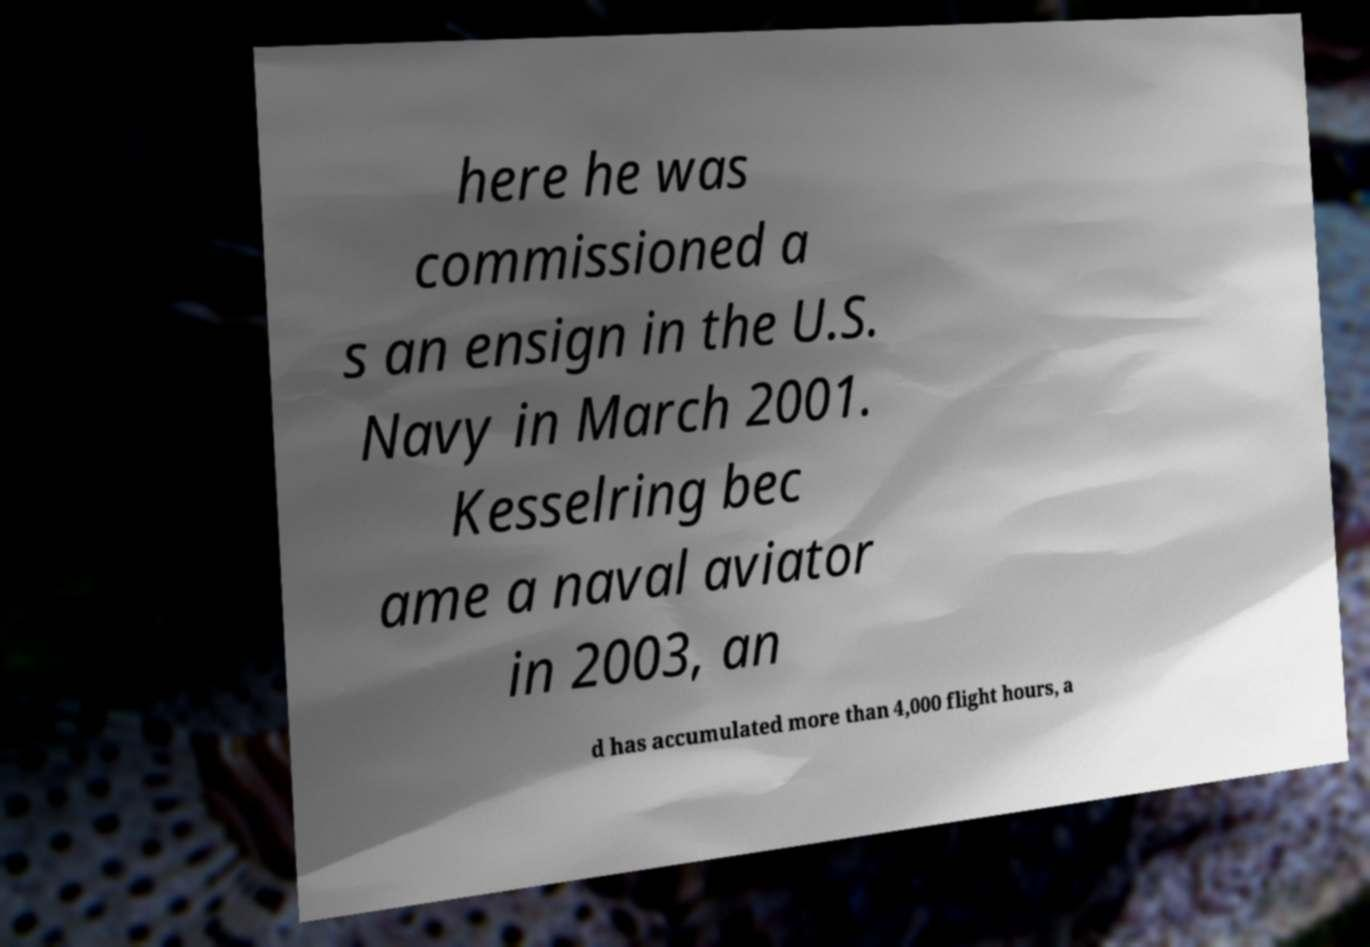Please identify and transcribe the text found in this image. here he was commissioned a s an ensign in the U.S. Navy in March 2001. Kesselring bec ame a naval aviator in 2003, an d has accumulated more than 4,000 flight hours, a 